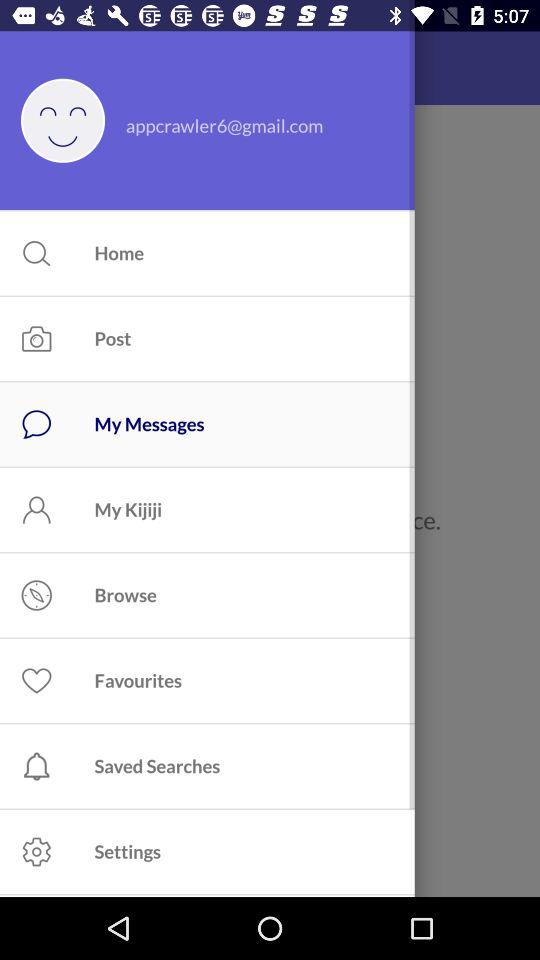Can we reset password?
When the provided information is insufficient, respond with <no answer>. <no answer> 